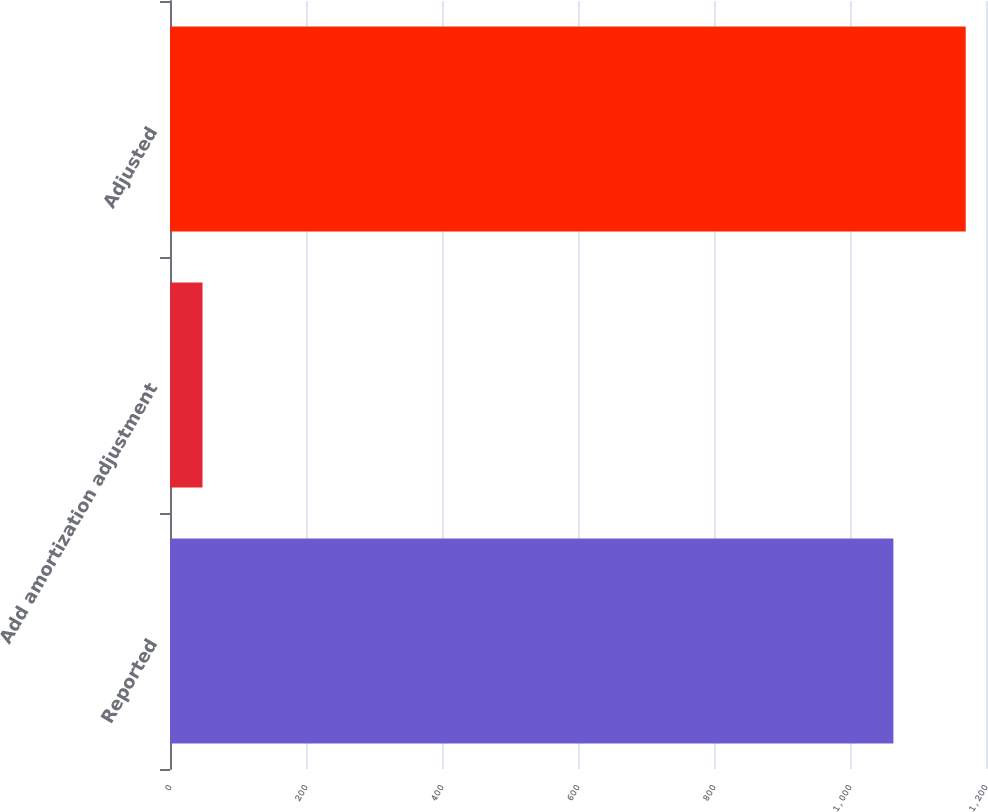Convert chart. <chart><loc_0><loc_0><loc_500><loc_500><bar_chart><fcel>Reported<fcel>Add amortization adjustment<fcel>Adjusted<nl><fcel>1063.8<fcel>47.8<fcel>1170.18<nl></chart> 